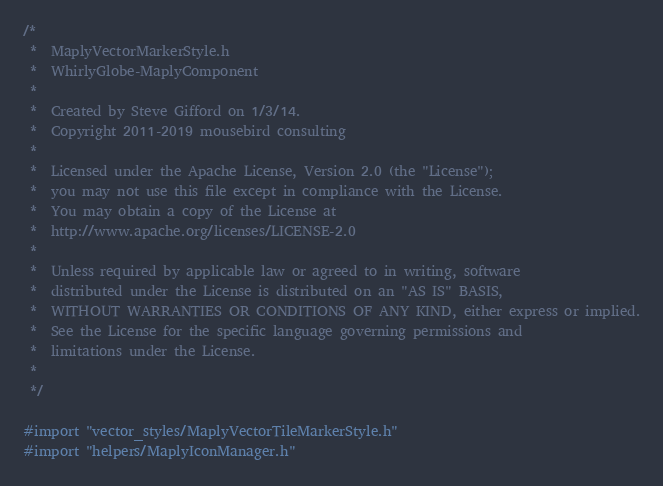<code> <loc_0><loc_0><loc_500><loc_500><_ObjectiveC_>/*
 *  MaplyVectorMarkerStyle.h
 *  WhirlyGlobe-MaplyComponent
 *
 *  Created by Steve Gifford on 1/3/14.
 *  Copyright 2011-2019 mousebird consulting
 *
 *  Licensed under the Apache License, Version 2.0 (the "License");
 *  you may not use this file except in compliance with the License.
 *  You may obtain a copy of the License at
 *  http://www.apache.org/licenses/LICENSE-2.0
 *
 *  Unless required by applicable law or agreed to in writing, software
 *  distributed under the License is distributed on an "AS IS" BASIS,
 *  WITHOUT WARRANTIES OR CONDITIONS OF ANY KIND, either express or implied.
 *  See the License for the specific language governing permissions and
 *  limitations under the License.
 *
 */

#import "vector_styles/MaplyVectorTileMarkerStyle.h"
#import "helpers/MaplyIconManager.h"</code> 